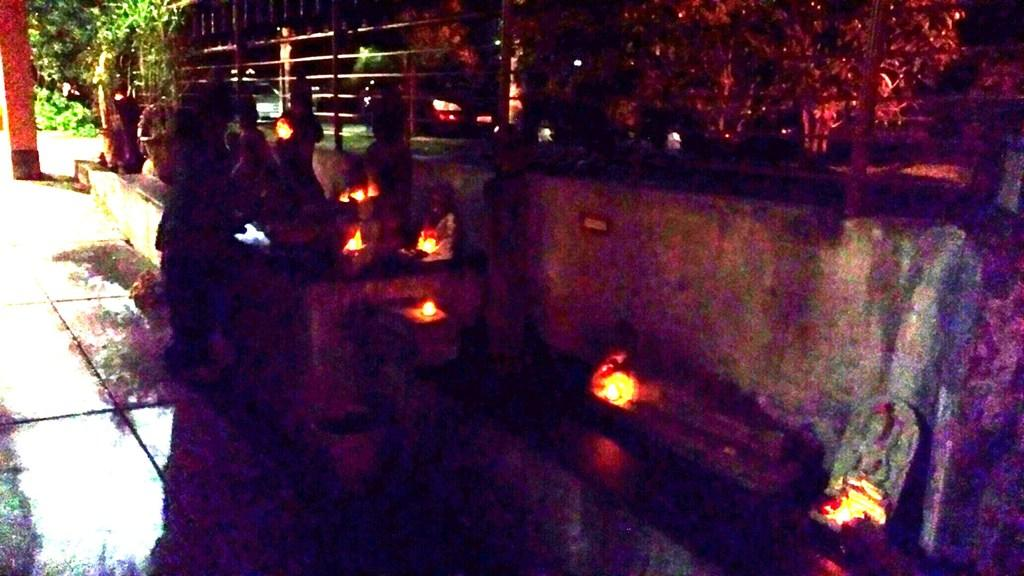What type of seating is present in the image? There is a bench in the image. Who or what is on the bench? There are persons sitting on the bench. What type of lighting is visible in the image? There are lights visible in the image, including colorful lights. What can be seen on the left side of the image? Trees are visible on the left side of the image. How many ladybugs are crawling on the bench in the image? There are no ladybugs present in the image; the focus is on the bench, persons sitting on it, and the lighting. 